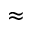<formula> <loc_0><loc_0><loc_500><loc_500>\approx</formula> 